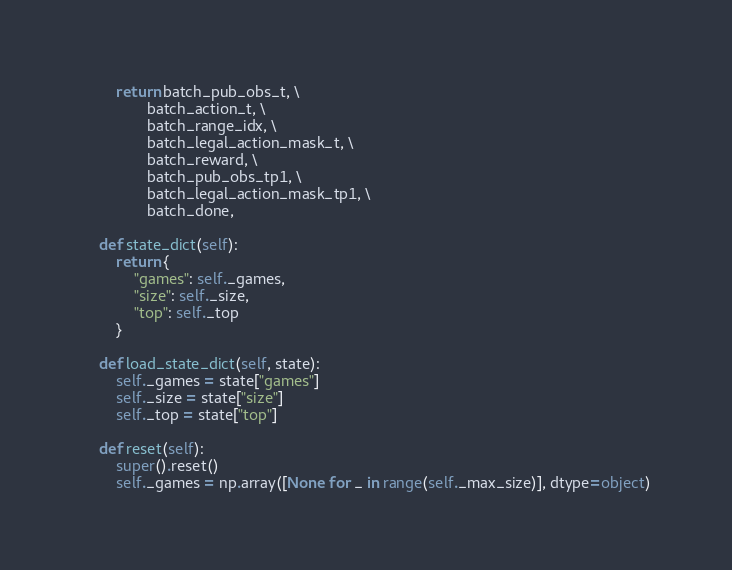Convert code to text. <code><loc_0><loc_0><loc_500><loc_500><_Python_>        return batch_pub_obs_t, \
               batch_action_t, \
               batch_range_idx, \
               batch_legal_action_mask_t, \
               batch_reward, \
               batch_pub_obs_tp1, \
               batch_legal_action_mask_tp1, \
               batch_done,

    def state_dict(self):
        return {
            "games": self._games,
            "size": self._size,
            "top": self._top
        }

    def load_state_dict(self, state):
        self._games = state["games"]
        self._size = state["size"]
        self._top = state["top"]

    def reset(self):
        super().reset()
        self._games = np.array([None for _ in range(self._max_size)], dtype=object)
</code> 